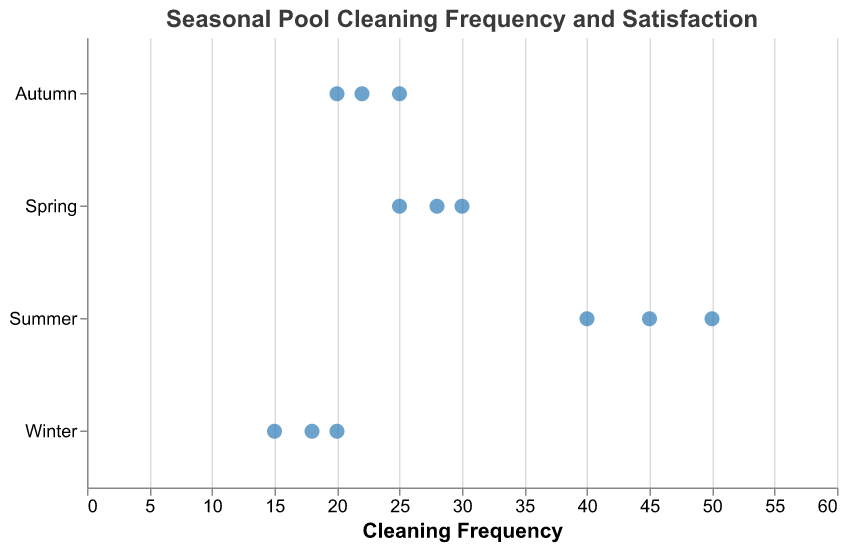How many seasons are displayed in the plot? The plot shows the data points categorized by season. The y-axis labels indicate the seasons.
Answer: 4 What is the title of the plot? The plot has a title at the top which provides a summary of what the plot is about.
Answer: Seasonal Pool Cleaning Frequency and Satisfaction Which season has the highest average satisfaction score based on the data points? Look at the tooltip or data points for each season and identify the highest value under the "Avg. Satisfaction" metric. Summer has satisfaction scores of 9.2, 9.0, and 9.5.
Answer: Summer What is the range of cleaning frequencies for Spring? The horizontal lines (rules) represent the range of frequencies for each season. For Spring, observe the range of horizontal positions.
Answer: 25 to 30 Compare the cleaning frequencies between Autumn and Winter. Which one has a wider range? For both Autumn and Winter, observe the range of their cleaning frequencies by looking at the horizontal lines.
Answer: Autumn What is the cleaning frequency associated with the highest satisfaction score for Summer? Identify the data point in Summer with the highest average satisfaction score and note its corresponding cleaning frequency.
Answer: 50 What is the average of the highest satisfaction scores across all seasons? Identify the highest satisfaction score for each season (Spring: 9.0, Summer: 9.5, Autumn: 8.3, Winter: 8.0), then calculate their average.
Answer: 8.7 How many data points are shown for each season? Count the number of points for each season on the plot. Each point represents a data entry.
Answer: 3 